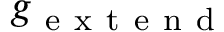Convert formula to latex. <formula><loc_0><loc_0><loc_500><loc_500>g _ { e x t e n d }</formula> 